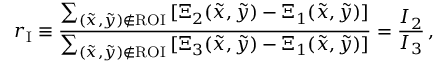Convert formula to latex. <formula><loc_0><loc_0><loc_500><loc_500>r _ { I } \equiv \frac { \sum _ { ( \tilde { x } , \tilde { y } ) \notin R O I } \, [ \Xi _ { 2 } ( \tilde { x } , \tilde { y } ) - \Xi _ { 1 } ( \tilde { x } , \tilde { y } ) ] } { \sum _ { ( \tilde { x } , \tilde { y } ) \notin R O I } \, [ \Xi _ { 3 } ( \tilde { x } , \tilde { y } ) - \Xi _ { 1 } ( \tilde { x } , \tilde { y } ) ] } = \frac { I _ { 2 } } { I _ { 3 } } \, ,</formula> 